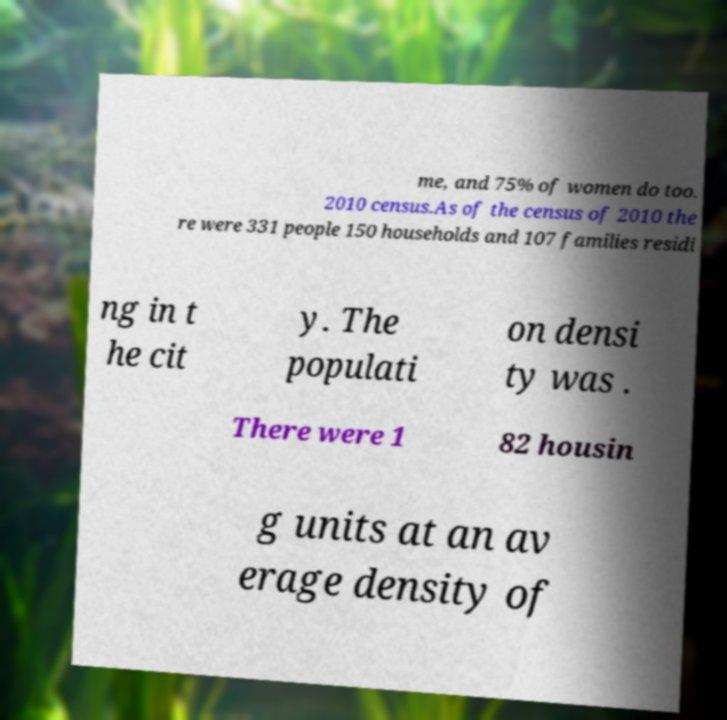For documentation purposes, I need the text within this image transcribed. Could you provide that? me, and 75% of women do too. 2010 census.As of the census of 2010 the re were 331 people 150 households and 107 families residi ng in t he cit y. The populati on densi ty was . There were 1 82 housin g units at an av erage density of 